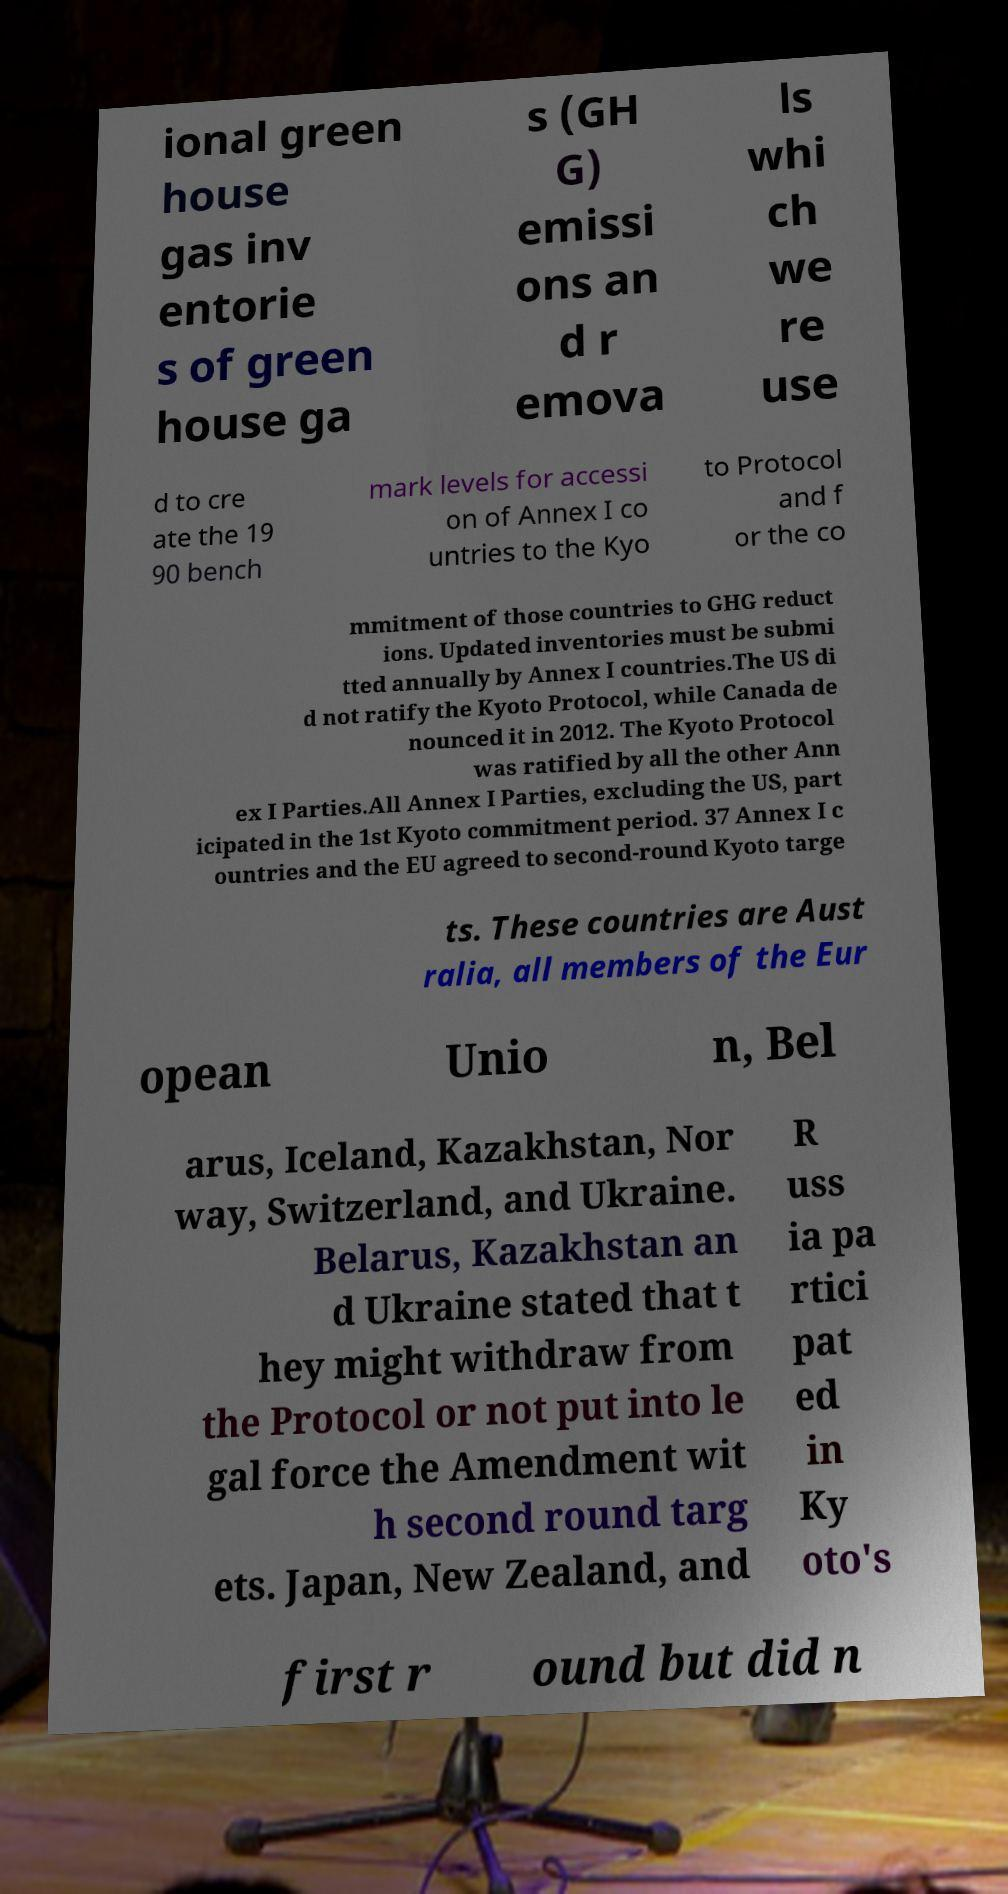Please identify and transcribe the text found in this image. ional green house gas inv entorie s of green house ga s (GH G) emissi ons an d r emova ls whi ch we re use d to cre ate the 19 90 bench mark levels for accessi on of Annex I co untries to the Kyo to Protocol and f or the co mmitment of those countries to GHG reduct ions. Updated inventories must be submi tted annually by Annex I countries.The US di d not ratify the Kyoto Protocol, while Canada de nounced it in 2012. The Kyoto Protocol was ratified by all the other Ann ex I Parties.All Annex I Parties, excluding the US, part icipated in the 1st Kyoto commitment period. 37 Annex I c ountries and the EU agreed to second-round Kyoto targe ts. These countries are Aust ralia, all members of the Eur opean Unio n, Bel arus, Iceland, Kazakhstan, Nor way, Switzerland, and Ukraine. Belarus, Kazakhstan an d Ukraine stated that t hey might withdraw from the Protocol or not put into le gal force the Amendment wit h second round targ ets. Japan, New Zealand, and R uss ia pa rtici pat ed in Ky oto's first r ound but did n 